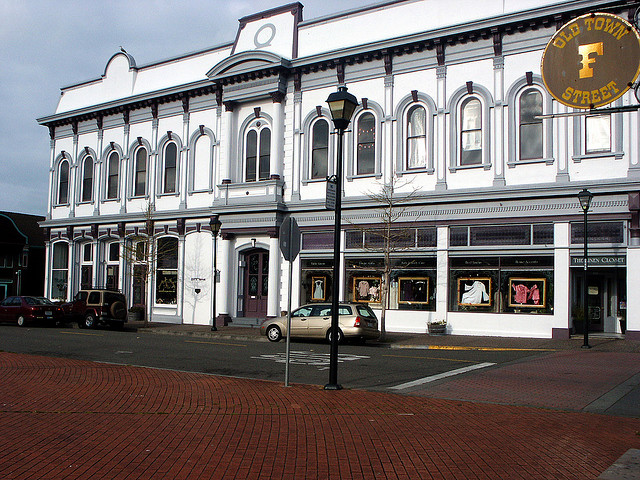Extract all visible text content from this image. OLD TOWN F STREET 